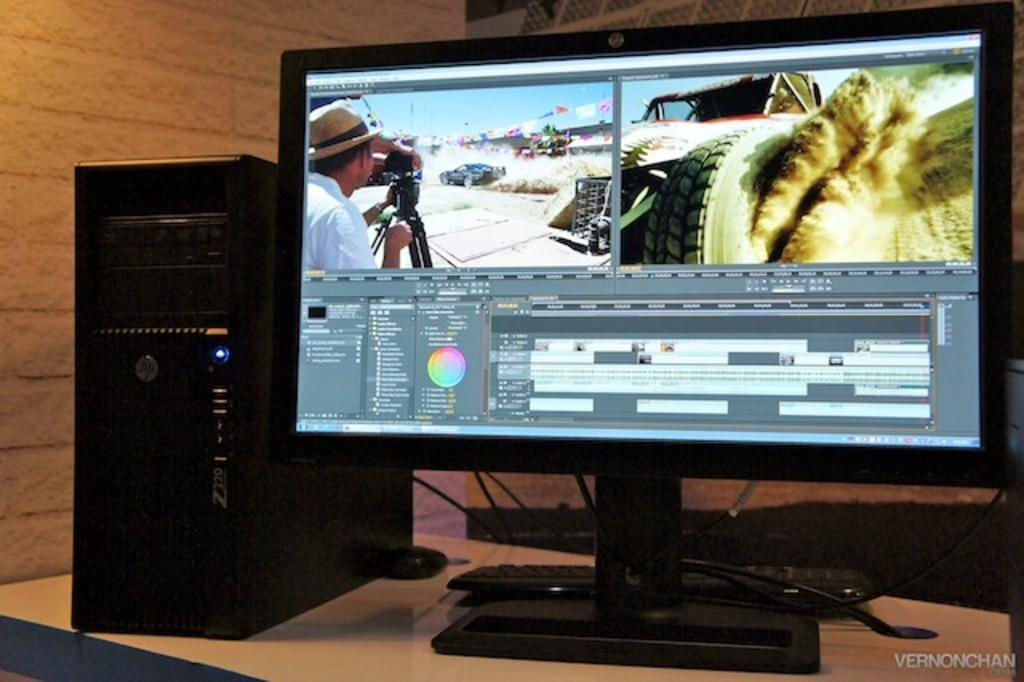<image>
Offer a succinct explanation of the picture presented. A Hp desktop monitor has a split screen showing a man taking a photo and a vehicle throwing dust from the tires as it drives. 